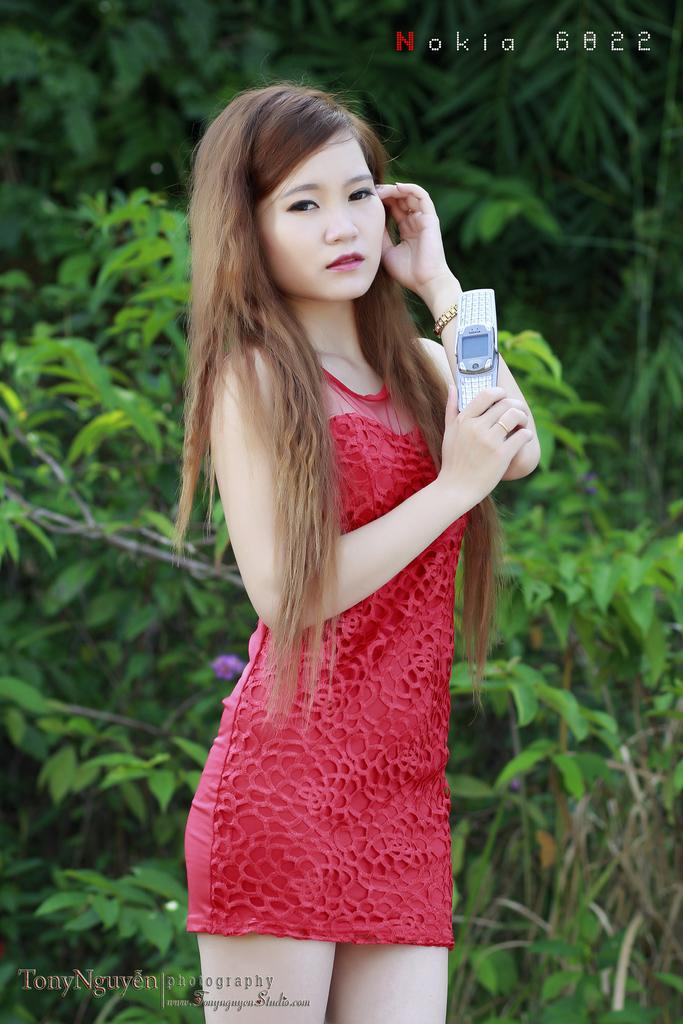Who is the main subject in the image? There is a girl in the image. What is the girl wearing? The girl is wearing a red dress. What is the girl holding in the image? The girl is holding a mobile. What can be seen in the background of the image? There are trees in the background of the image. What channel is the girl watching on the mobile in the image? There is no indication in the image that the girl is watching a channel on the mobile. 